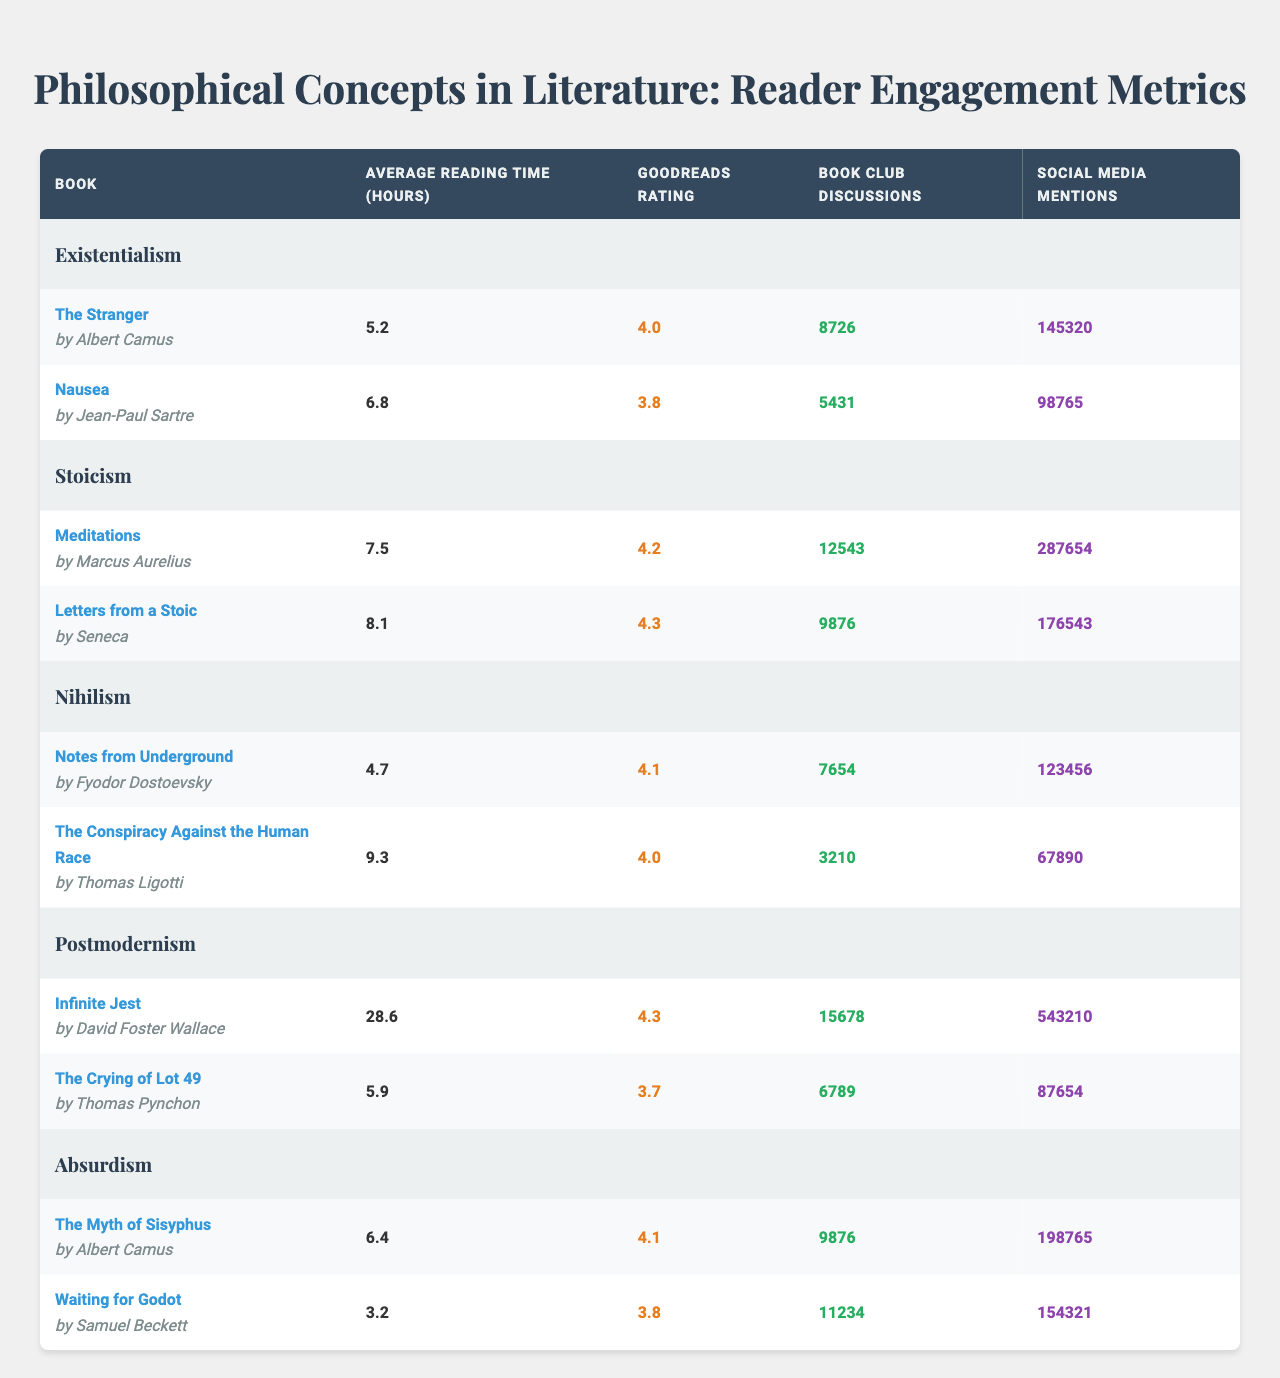What is the Goodreads rating for "Meditations"? The Goodreads rating for "Meditations" by Marcus Aurelius is listed in the table as 4.2
Answer: 4.2 Which book has the highest average reading time? "Infinite Jest" by David Foster Wallace has the highest average reading time at 28.6 hours, which is the maximum value in the "Average Reading Time" column
Answer: 28.6 How many book club discussions are there for "Waiting for Godot"? "Waiting for Godot" by Samuel Beckett has 11,234 book club discussions recorded in the table
Answer: 11234 What is the average Goodreads rating of the books under Stoicism? The books under Stoicism are "Meditations" (4.2) and "Letters from a Stoic" (4.3). Their average is calculated as (4.2 + 4.3) / 2 = 4.25
Answer: 4.25 Is the total number of social media mentions for all books on Absurdism greater than 300,000? The total social media mentions for "The Myth of Sisyphus" (198,765) and "Waiting for Godot" (154,321) is 198,765 + 154,321 = 353,086, which is greater than 300,000
Answer: Yes What is the difference in average reading time between "Notes from Underground" and "The Conspiracy Against the Human Race"? The average reading time for "Notes from Underground" is 4.7 hours and for "The Conspiracy Against the Human Race" is 9.3 hours. The difference is 9.3 - 4.7 = 4.6 hours
Answer: 4.6 Count the total number of book club discussions for all Existentialism books. "The Stranger" has 8,726 discussions and "Nausea" has 5,431 discussions. Adding them gives 8,726 + 5,431 = 14,157 discussions
Answer: 14157 Which concept has the highest total social media mentions when summing up all its books? Postmodernism features "Infinite Jest" (543,210) and "The Crying of Lot 49" (87,654). The total for Postmodernism is 543,210 + 87,654 = 630,864, which is the highest among the concepts listed
Answer: Postmodernism What is the ratio of average reading time of "The Crying of Lot 49" to "Nausea"? The average reading time for "The Crying of Lot 49" is 5.9 hours and for "Nausea" is 6.8 hours. The ratio is calculated as 5.9 / 6.8 = 0.867
Answer: 0.867 Are there more book club discussions for the book "The Stranger" than for "Nausea"? "The Stranger" has 8,726 discussions while "Nausea" has 5,431 discussions. Since 8,726 is greater than 5,431, the answer is yes
Answer: Yes 